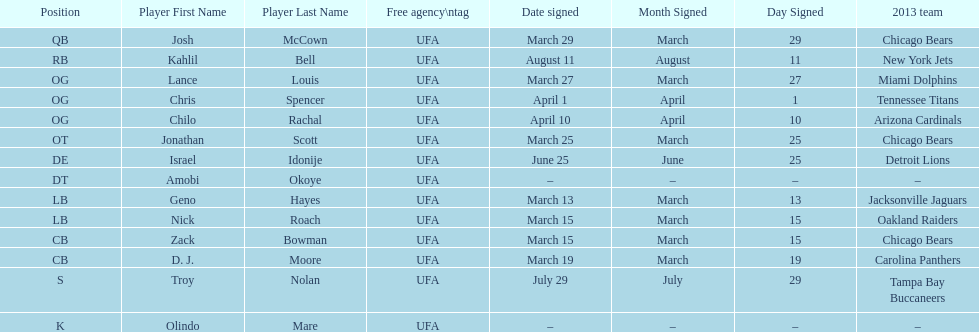What is the total of 2013 teams on the chart? 10. 